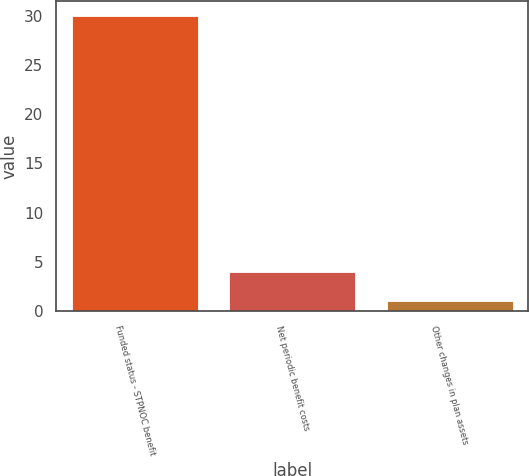Convert chart to OTSL. <chart><loc_0><loc_0><loc_500><loc_500><bar_chart><fcel>Funded status - STPNOC benefit<fcel>Net periodic benefit costs<fcel>Other changes in plan assets<nl><fcel>30<fcel>4<fcel>1<nl></chart> 